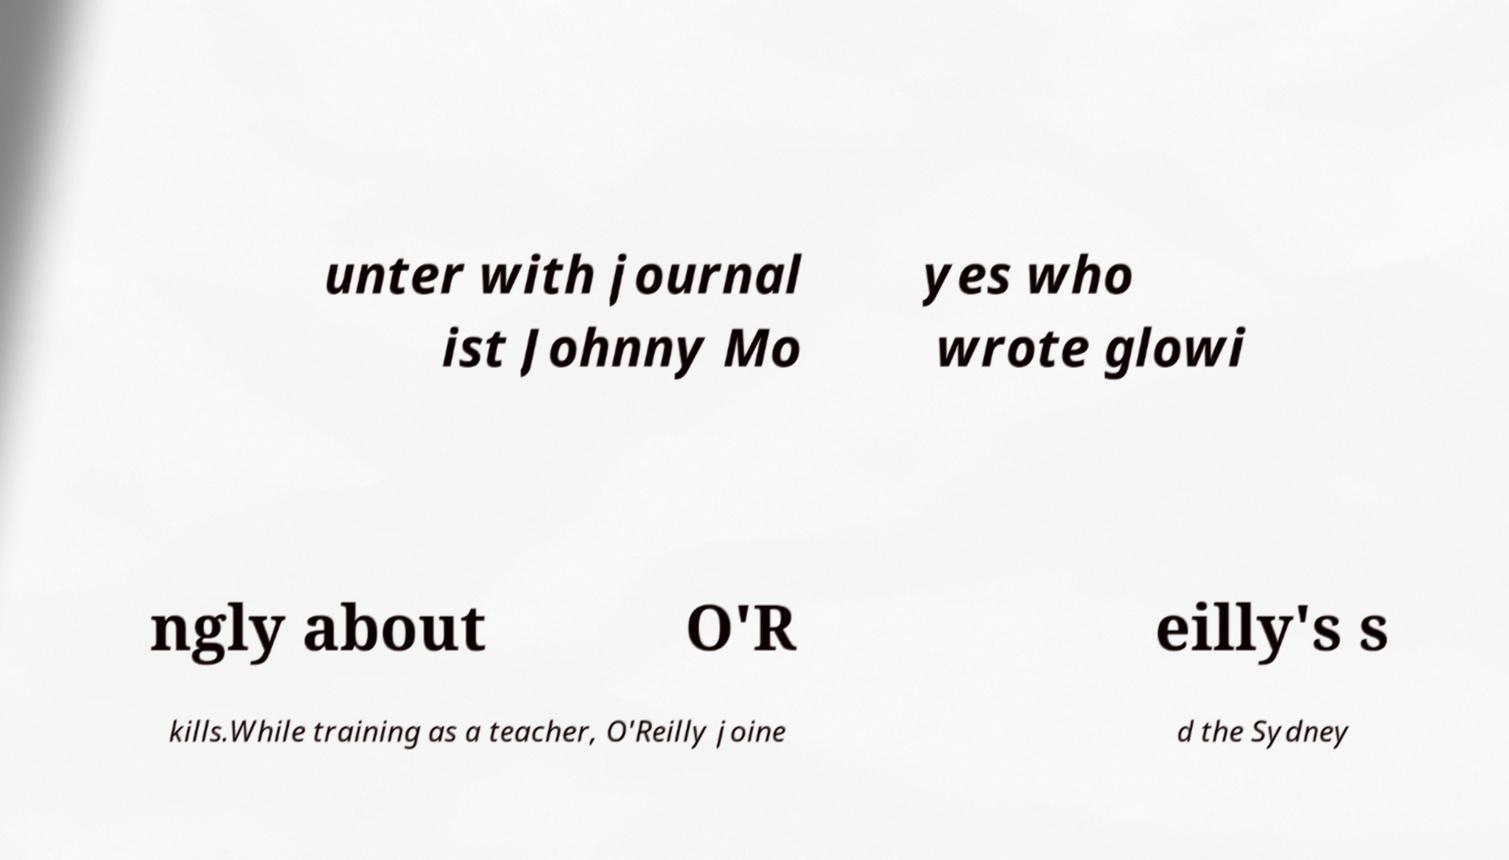Could you extract and type out the text from this image? unter with journal ist Johnny Mo yes who wrote glowi ngly about O'R eilly's s kills.While training as a teacher, O'Reilly joine d the Sydney 